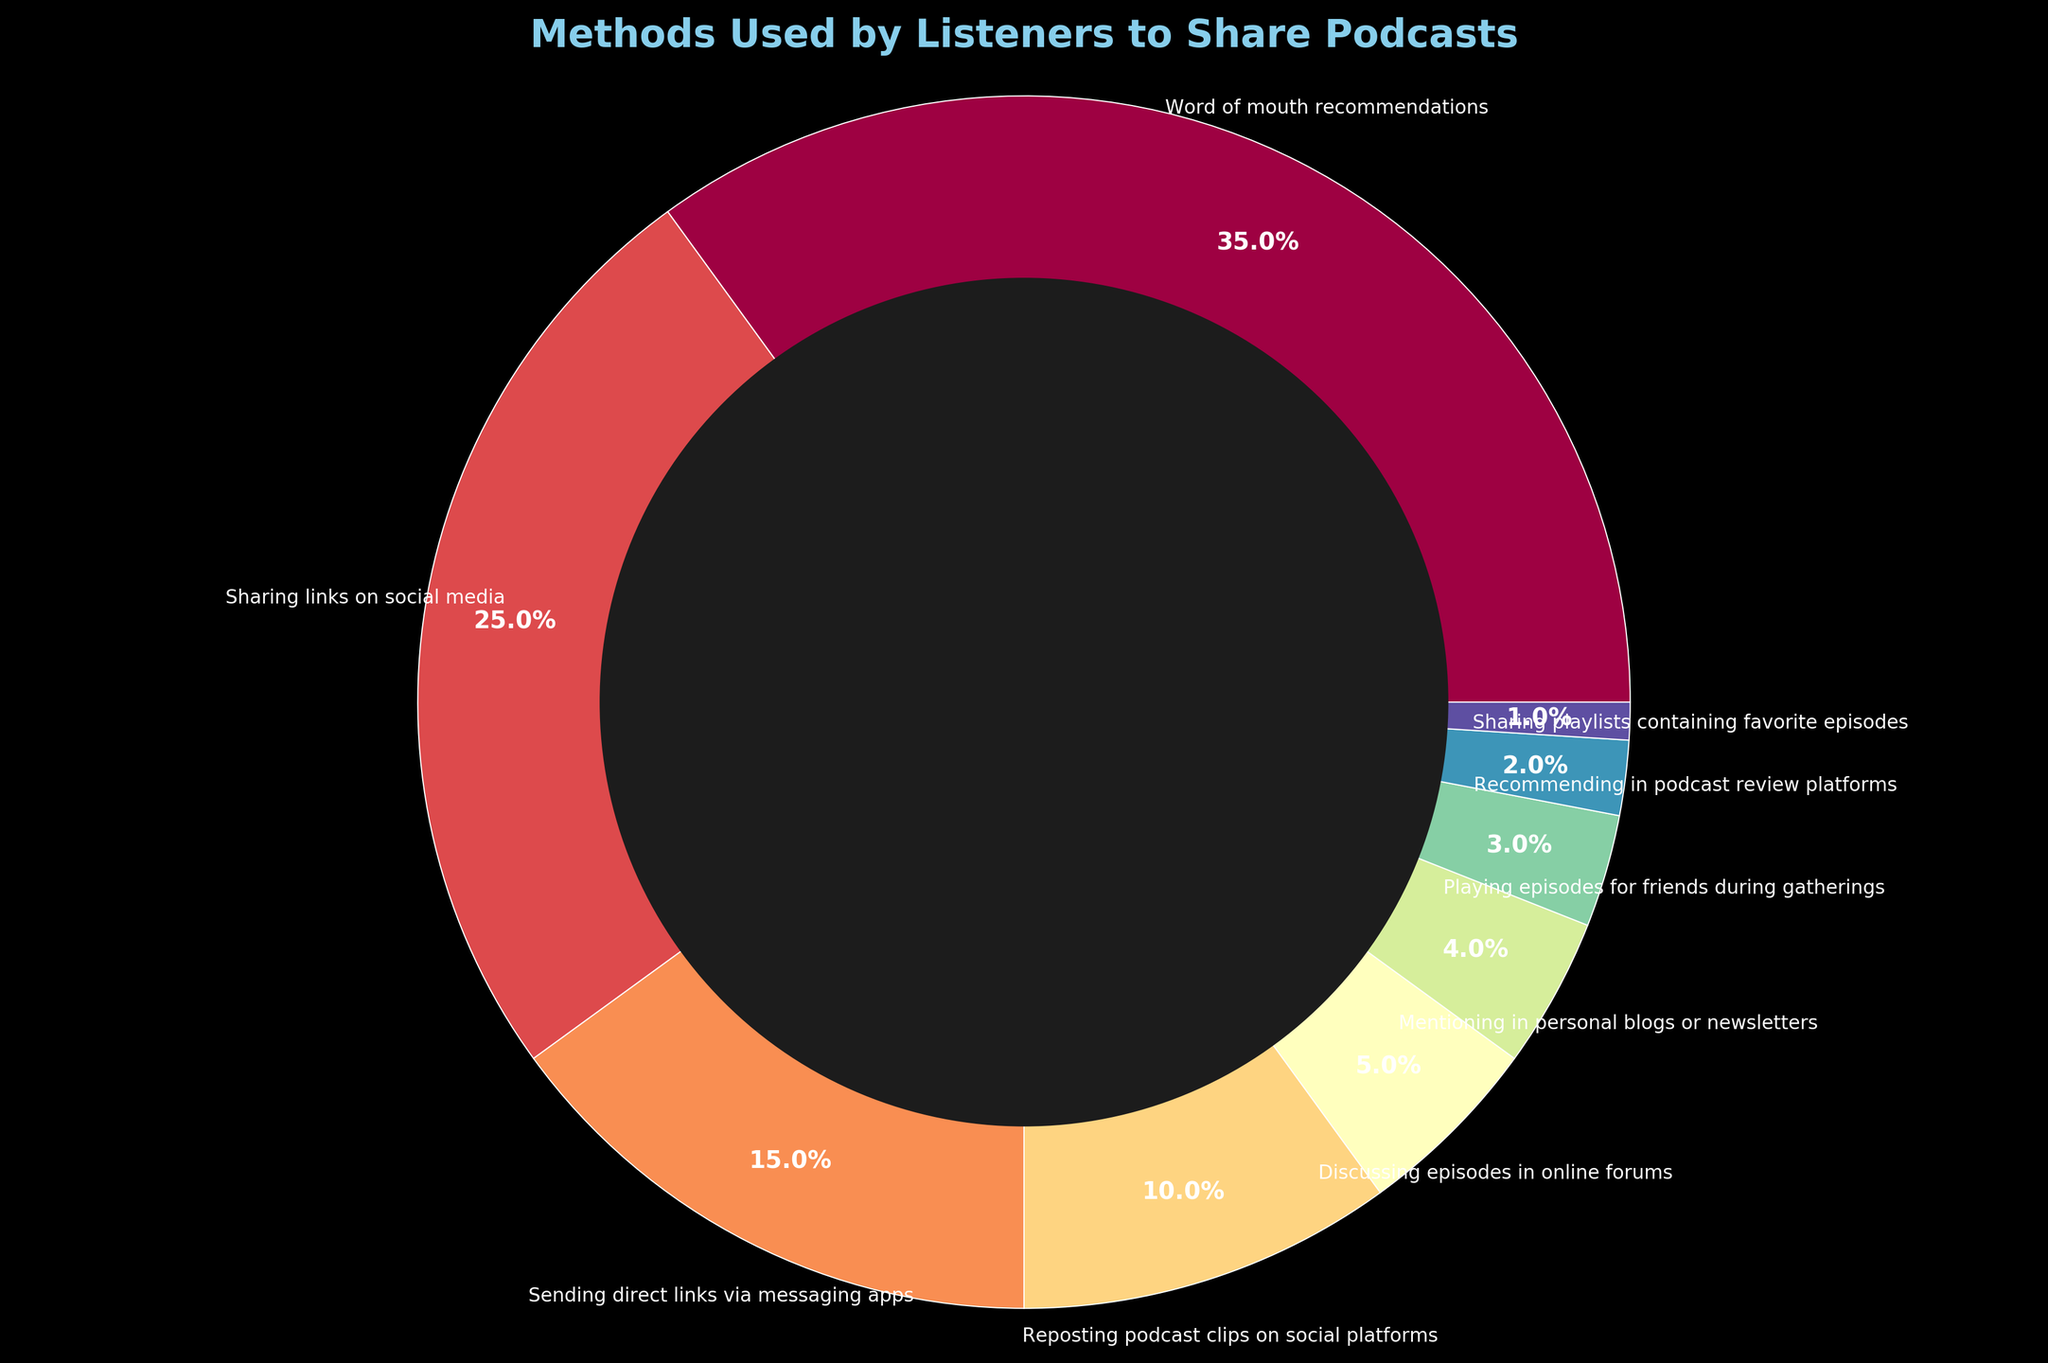How many methods have less than 5% usage? First, identify all methods from the chart that represent less than 5%. There are five categories: "Discussing episodes in online forums" (5%), "Mentioning in personal blogs or newsletters" (4%), "Playing episodes for friends during gatherings" (3%), "Recommending in podcast review platforms" (2%), and "Sharing playlists containing favorite episodes" (1%)
Answer: 5 Which method is used the most by listeners to share podcasts? Look at the segment with the largest percentage on the pie chart. The “Word of mouth recommendations” section shows the highest value at 35%
Answer: Word of mouth recommendations What's the combined percentage of methods involving social media? Add the percentages of "Sharing links on social media" (25%), "Reposting podcast clips on social platforms" (10%), and "Discussing episodes in online forums" (5%). The sum is 25% + 10% + 5% = 40%
Answer: 40% Which sharing method shows the smallest percentage? Identify the segment with the smallest visible percentage on the chart. "Sharing playlists containing favorite episodes" has the smallest value at 1%
Answer: Sharing playlists containing favorite episodes What is the difference in percentage between "Sharing links on social media" and "Sending direct links via messaging apps"? Subtract the percentage for "Sending direct links via messaging apps" (15%) from the percentage for "Sharing links on social media" (25%). The difference is 25% - 15% = 10%
Answer: 10% What is the total percentage of methods that involve direct interaction (word of mouth and playing episodes for friends)? Add the percentages of "Word of mouth recommendations" (35%) and "Playing episodes for friends during gatherings" (3%). The sum is 35% + 3% = 38%
Answer: 38% Which two categories have a total combined percentage of 20%? Find two categories whose percentages add up to 20%. Reposting podcast clips on social platforms (10%) and Sending direct links via messaging apps (15%) doesn't match. Using "Discussing episodes in online forums" (5%) and "Playing episodes for friends during gatherings" (3%) gives 5% + 3% = 8%, which also doesn't match. "Reposting podcast clips on social platforms" (10%) and "Sending direct links via messaging apps" (15%) give 10%+15%=25%, which also does not work. Therefore, the only possible categories are "Sending direct links via messaging apps" (15%) and "Discussing episodes in online forums" (5%) with a total of 15%+5%=20%
Answer: Sending direct links via messaging apps and Discussing episodes in online forums 